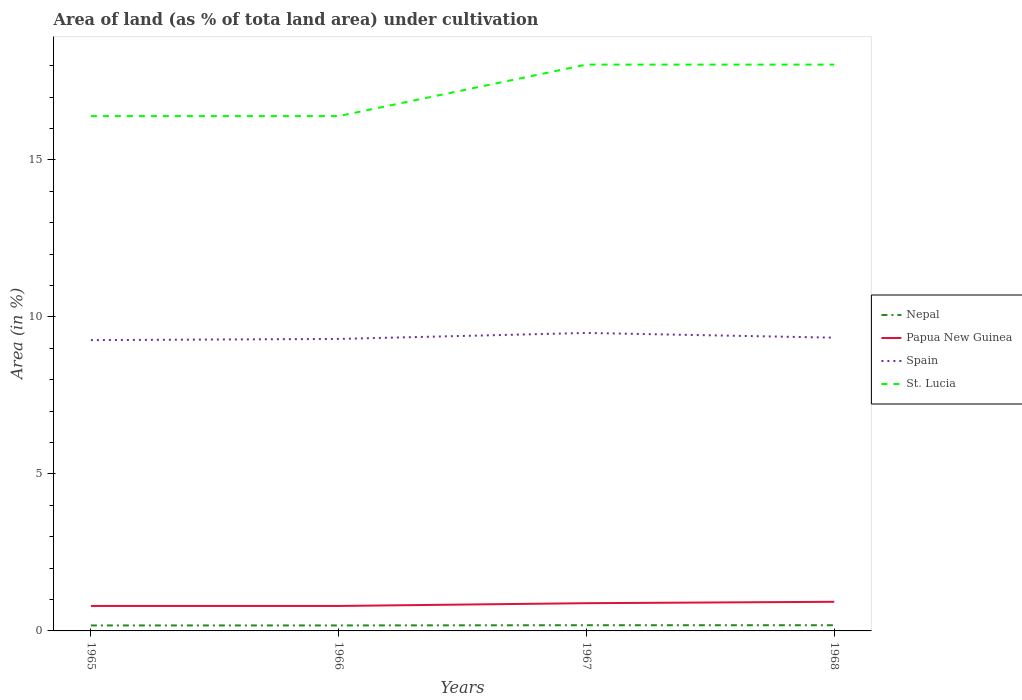Is the number of lines equal to the number of legend labels?
Ensure brevity in your answer.  Yes. Across all years, what is the maximum percentage of land under cultivation in Spain?
Offer a very short reply. 9.26. In which year was the percentage of land under cultivation in Papua New Guinea maximum?
Your answer should be very brief. 1965. What is the total percentage of land under cultivation in St. Lucia in the graph?
Your response must be concise. 0. What is the difference between the highest and the second highest percentage of land under cultivation in Papua New Guinea?
Provide a succinct answer. 0.13. Is the percentage of land under cultivation in Spain strictly greater than the percentage of land under cultivation in St. Lucia over the years?
Your answer should be compact. Yes. Does the graph contain grids?
Provide a succinct answer. No. Where does the legend appear in the graph?
Offer a terse response. Center right. How many legend labels are there?
Provide a succinct answer. 4. What is the title of the graph?
Provide a succinct answer. Area of land (as % of tota land area) under cultivation. What is the label or title of the Y-axis?
Your answer should be very brief. Area (in %). What is the Area (in %) in Nepal in 1965?
Your response must be concise. 0.17. What is the Area (in %) in Papua New Guinea in 1965?
Provide a succinct answer. 0.79. What is the Area (in %) in Spain in 1965?
Your response must be concise. 9.26. What is the Area (in %) of St. Lucia in 1965?
Give a very brief answer. 16.39. What is the Area (in %) in Nepal in 1966?
Make the answer very short. 0.17. What is the Area (in %) in Papua New Guinea in 1966?
Give a very brief answer. 0.79. What is the Area (in %) in Spain in 1966?
Provide a succinct answer. 9.3. What is the Area (in %) in St. Lucia in 1966?
Provide a short and direct response. 16.39. What is the Area (in %) of Nepal in 1967?
Your answer should be very brief. 0.18. What is the Area (in %) in Papua New Guinea in 1967?
Your answer should be very brief. 0.88. What is the Area (in %) of Spain in 1967?
Your answer should be compact. 9.49. What is the Area (in %) in St. Lucia in 1967?
Offer a very short reply. 18.03. What is the Area (in %) of Nepal in 1968?
Ensure brevity in your answer.  0.18. What is the Area (in %) in Papua New Guinea in 1968?
Provide a short and direct response. 0.93. What is the Area (in %) of Spain in 1968?
Offer a very short reply. 9.34. What is the Area (in %) of St. Lucia in 1968?
Keep it short and to the point. 18.03. Across all years, what is the maximum Area (in %) in Nepal?
Make the answer very short. 0.18. Across all years, what is the maximum Area (in %) in Papua New Guinea?
Keep it short and to the point. 0.93. Across all years, what is the maximum Area (in %) in Spain?
Your answer should be compact. 9.49. Across all years, what is the maximum Area (in %) of St. Lucia?
Ensure brevity in your answer.  18.03. Across all years, what is the minimum Area (in %) of Nepal?
Ensure brevity in your answer.  0.17. Across all years, what is the minimum Area (in %) of Papua New Guinea?
Keep it short and to the point. 0.79. Across all years, what is the minimum Area (in %) in Spain?
Give a very brief answer. 9.26. Across all years, what is the minimum Area (in %) in St. Lucia?
Offer a very short reply. 16.39. What is the total Area (in %) of Nepal in the graph?
Ensure brevity in your answer.  0.71. What is the total Area (in %) in Papua New Guinea in the graph?
Give a very brief answer. 3.4. What is the total Area (in %) in Spain in the graph?
Your answer should be very brief. 37.38. What is the total Area (in %) in St. Lucia in the graph?
Provide a short and direct response. 68.85. What is the difference between the Area (in %) of Nepal in 1965 and that in 1966?
Offer a terse response. 0. What is the difference between the Area (in %) in Spain in 1965 and that in 1966?
Your answer should be compact. -0.04. What is the difference between the Area (in %) of Nepal in 1965 and that in 1967?
Your response must be concise. -0.01. What is the difference between the Area (in %) in Papua New Guinea in 1965 and that in 1967?
Offer a terse response. -0.09. What is the difference between the Area (in %) in Spain in 1965 and that in 1967?
Make the answer very short. -0.23. What is the difference between the Area (in %) of St. Lucia in 1965 and that in 1967?
Offer a very short reply. -1.64. What is the difference between the Area (in %) of Nepal in 1965 and that in 1968?
Make the answer very short. -0.01. What is the difference between the Area (in %) of Papua New Guinea in 1965 and that in 1968?
Your answer should be compact. -0.13. What is the difference between the Area (in %) of Spain in 1965 and that in 1968?
Your response must be concise. -0.08. What is the difference between the Area (in %) in St. Lucia in 1965 and that in 1968?
Make the answer very short. -1.64. What is the difference between the Area (in %) in Nepal in 1966 and that in 1967?
Give a very brief answer. -0.01. What is the difference between the Area (in %) in Papua New Guinea in 1966 and that in 1967?
Provide a short and direct response. -0.09. What is the difference between the Area (in %) in Spain in 1966 and that in 1967?
Make the answer very short. -0.19. What is the difference between the Area (in %) in St. Lucia in 1966 and that in 1967?
Provide a succinct answer. -1.64. What is the difference between the Area (in %) in Nepal in 1966 and that in 1968?
Your response must be concise. -0.01. What is the difference between the Area (in %) of Papua New Guinea in 1966 and that in 1968?
Your answer should be very brief. -0.13. What is the difference between the Area (in %) in Spain in 1966 and that in 1968?
Make the answer very short. -0.04. What is the difference between the Area (in %) in St. Lucia in 1966 and that in 1968?
Your response must be concise. -1.64. What is the difference between the Area (in %) in Nepal in 1967 and that in 1968?
Provide a succinct answer. 0. What is the difference between the Area (in %) of Papua New Guinea in 1967 and that in 1968?
Your answer should be compact. -0.04. What is the difference between the Area (in %) in Spain in 1967 and that in 1968?
Your answer should be very brief. 0.15. What is the difference between the Area (in %) in St. Lucia in 1967 and that in 1968?
Ensure brevity in your answer.  0. What is the difference between the Area (in %) in Nepal in 1965 and the Area (in %) in Papua New Guinea in 1966?
Your answer should be compact. -0.62. What is the difference between the Area (in %) in Nepal in 1965 and the Area (in %) in Spain in 1966?
Provide a succinct answer. -9.12. What is the difference between the Area (in %) in Nepal in 1965 and the Area (in %) in St. Lucia in 1966?
Offer a terse response. -16.22. What is the difference between the Area (in %) of Papua New Guinea in 1965 and the Area (in %) of Spain in 1966?
Ensure brevity in your answer.  -8.5. What is the difference between the Area (in %) in Papua New Guinea in 1965 and the Area (in %) in St. Lucia in 1966?
Offer a very short reply. -15.6. What is the difference between the Area (in %) of Spain in 1965 and the Area (in %) of St. Lucia in 1966?
Ensure brevity in your answer.  -7.13. What is the difference between the Area (in %) of Nepal in 1965 and the Area (in %) of Papua New Guinea in 1967?
Make the answer very short. -0.71. What is the difference between the Area (in %) in Nepal in 1965 and the Area (in %) in Spain in 1967?
Your answer should be compact. -9.31. What is the difference between the Area (in %) of Nepal in 1965 and the Area (in %) of St. Lucia in 1967?
Ensure brevity in your answer.  -17.86. What is the difference between the Area (in %) in Papua New Guinea in 1965 and the Area (in %) in Spain in 1967?
Ensure brevity in your answer.  -8.69. What is the difference between the Area (in %) of Papua New Guinea in 1965 and the Area (in %) of St. Lucia in 1967?
Give a very brief answer. -17.24. What is the difference between the Area (in %) in Spain in 1965 and the Area (in %) in St. Lucia in 1967?
Provide a succinct answer. -8.77. What is the difference between the Area (in %) of Nepal in 1965 and the Area (in %) of Papua New Guinea in 1968?
Your answer should be compact. -0.75. What is the difference between the Area (in %) in Nepal in 1965 and the Area (in %) in Spain in 1968?
Offer a very short reply. -9.16. What is the difference between the Area (in %) in Nepal in 1965 and the Area (in %) in St. Lucia in 1968?
Provide a succinct answer. -17.86. What is the difference between the Area (in %) of Papua New Guinea in 1965 and the Area (in %) of Spain in 1968?
Provide a succinct answer. -8.54. What is the difference between the Area (in %) in Papua New Guinea in 1965 and the Area (in %) in St. Lucia in 1968?
Provide a short and direct response. -17.24. What is the difference between the Area (in %) in Spain in 1965 and the Area (in %) in St. Lucia in 1968?
Offer a very short reply. -8.77. What is the difference between the Area (in %) of Nepal in 1966 and the Area (in %) of Papua New Guinea in 1967?
Make the answer very short. -0.71. What is the difference between the Area (in %) of Nepal in 1966 and the Area (in %) of Spain in 1967?
Give a very brief answer. -9.31. What is the difference between the Area (in %) of Nepal in 1966 and the Area (in %) of St. Lucia in 1967?
Your answer should be compact. -17.86. What is the difference between the Area (in %) in Papua New Guinea in 1966 and the Area (in %) in Spain in 1967?
Make the answer very short. -8.69. What is the difference between the Area (in %) of Papua New Guinea in 1966 and the Area (in %) of St. Lucia in 1967?
Your answer should be compact. -17.24. What is the difference between the Area (in %) of Spain in 1966 and the Area (in %) of St. Lucia in 1967?
Provide a short and direct response. -8.73. What is the difference between the Area (in %) of Nepal in 1966 and the Area (in %) of Papua New Guinea in 1968?
Your answer should be compact. -0.75. What is the difference between the Area (in %) of Nepal in 1966 and the Area (in %) of Spain in 1968?
Provide a short and direct response. -9.16. What is the difference between the Area (in %) in Nepal in 1966 and the Area (in %) in St. Lucia in 1968?
Your answer should be compact. -17.86. What is the difference between the Area (in %) of Papua New Guinea in 1966 and the Area (in %) of Spain in 1968?
Provide a succinct answer. -8.54. What is the difference between the Area (in %) in Papua New Guinea in 1966 and the Area (in %) in St. Lucia in 1968?
Provide a succinct answer. -17.24. What is the difference between the Area (in %) of Spain in 1966 and the Area (in %) of St. Lucia in 1968?
Make the answer very short. -8.73. What is the difference between the Area (in %) in Nepal in 1967 and the Area (in %) in Papua New Guinea in 1968?
Provide a succinct answer. -0.75. What is the difference between the Area (in %) in Nepal in 1967 and the Area (in %) in Spain in 1968?
Your answer should be compact. -9.16. What is the difference between the Area (in %) of Nepal in 1967 and the Area (in %) of St. Lucia in 1968?
Provide a succinct answer. -17.85. What is the difference between the Area (in %) in Papua New Guinea in 1967 and the Area (in %) in Spain in 1968?
Your response must be concise. -8.45. What is the difference between the Area (in %) in Papua New Guinea in 1967 and the Area (in %) in St. Lucia in 1968?
Keep it short and to the point. -17.15. What is the difference between the Area (in %) of Spain in 1967 and the Area (in %) of St. Lucia in 1968?
Your answer should be compact. -8.54. What is the average Area (in %) in Nepal per year?
Your answer should be compact. 0.18. What is the average Area (in %) in Papua New Guinea per year?
Ensure brevity in your answer.  0.85. What is the average Area (in %) of Spain per year?
Your answer should be compact. 9.35. What is the average Area (in %) of St. Lucia per year?
Keep it short and to the point. 17.21. In the year 1965, what is the difference between the Area (in %) of Nepal and Area (in %) of Papua New Guinea?
Make the answer very short. -0.62. In the year 1965, what is the difference between the Area (in %) in Nepal and Area (in %) in Spain?
Provide a succinct answer. -9.09. In the year 1965, what is the difference between the Area (in %) of Nepal and Area (in %) of St. Lucia?
Your answer should be very brief. -16.22. In the year 1965, what is the difference between the Area (in %) of Papua New Guinea and Area (in %) of Spain?
Your response must be concise. -8.47. In the year 1965, what is the difference between the Area (in %) in Papua New Guinea and Area (in %) in St. Lucia?
Your answer should be very brief. -15.6. In the year 1965, what is the difference between the Area (in %) of Spain and Area (in %) of St. Lucia?
Provide a short and direct response. -7.13. In the year 1966, what is the difference between the Area (in %) of Nepal and Area (in %) of Papua New Guinea?
Make the answer very short. -0.62. In the year 1966, what is the difference between the Area (in %) of Nepal and Area (in %) of Spain?
Ensure brevity in your answer.  -9.12. In the year 1966, what is the difference between the Area (in %) of Nepal and Area (in %) of St. Lucia?
Keep it short and to the point. -16.22. In the year 1966, what is the difference between the Area (in %) in Papua New Guinea and Area (in %) in Spain?
Your answer should be very brief. -8.5. In the year 1966, what is the difference between the Area (in %) in Papua New Guinea and Area (in %) in St. Lucia?
Provide a short and direct response. -15.6. In the year 1966, what is the difference between the Area (in %) of Spain and Area (in %) of St. Lucia?
Offer a very short reply. -7.1. In the year 1967, what is the difference between the Area (in %) in Nepal and Area (in %) in Papua New Guinea?
Ensure brevity in your answer.  -0.7. In the year 1967, what is the difference between the Area (in %) of Nepal and Area (in %) of Spain?
Ensure brevity in your answer.  -9.31. In the year 1967, what is the difference between the Area (in %) of Nepal and Area (in %) of St. Lucia?
Your response must be concise. -17.85. In the year 1967, what is the difference between the Area (in %) of Papua New Guinea and Area (in %) of Spain?
Keep it short and to the point. -8.6. In the year 1967, what is the difference between the Area (in %) in Papua New Guinea and Area (in %) in St. Lucia?
Offer a terse response. -17.15. In the year 1967, what is the difference between the Area (in %) in Spain and Area (in %) in St. Lucia?
Offer a very short reply. -8.54. In the year 1968, what is the difference between the Area (in %) in Nepal and Area (in %) in Papua New Guinea?
Provide a short and direct response. -0.75. In the year 1968, what is the difference between the Area (in %) of Nepal and Area (in %) of Spain?
Provide a succinct answer. -9.16. In the year 1968, what is the difference between the Area (in %) of Nepal and Area (in %) of St. Lucia?
Give a very brief answer. -17.85. In the year 1968, what is the difference between the Area (in %) of Papua New Guinea and Area (in %) of Spain?
Your response must be concise. -8.41. In the year 1968, what is the difference between the Area (in %) in Papua New Guinea and Area (in %) in St. Lucia?
Ensure brevity in your answer.  -17.11. In the year 1968, what is the difference between the Area (in %) of Spain and Area (in %) of St. Lucia?
Provide a short and direct response. -8.69. What is the ratio of the Area (in %) in Nepal in 1965 to that in 1966?
Your answer should be compact. 1. What is the ratio of the Area (in %) of Nepal in 1965 to that in 1967?
Provide a short and direct response. 0.96. What is the ratio of the Area (in %) in Papua New Guinea in 1965 to that in 1967?
Offer a terse response. 0.9. What is the ratio of the Area (in %) in Spain in 1965 to that in 1967?
Your response must be concise. 0.98. What is the ratio of the Area (in %) in St. Lucia in 1965 to that in 1967?
Your response must be concise. 0.91. What is the ratio of the Area (in %) of Nepal in 1965 to that in 1968?
Give a very brief answer. 0.96. What is the ratio of the Area (in %) in Papua New Guinea in 1965 to that in 1968?
Make the answer very short. 0.86. What is the ratio of the Area (in %) in Spain in 1965 to that in 1968?
Keep it short and to the point. 0.99. What is the ratio of the Area (in %) of St. Lucia in 1965 to that in 1968?
Keep it short and to the point. 0.91. What is the ratio of the Area (in %) of Nepal in 1966 to that in 1967?
Provide a succinct answer. 0.96. What is the ratio of the Area (in %) in Spain in 1966 to that in 1967?
Offer a terse response. 0.98. What is the ratio of the Area (in %) in St. Lucia in 1966 to that in 1967?
Give a very brief answer. 0.91. What is the ratio of the Area (in %) of Nepal in 1966 to that in 1968?
Offer a terse response. 0.96. What is the ratio of the Area (in %) in Spain in 1967 to that in 1968?
Your response must be concise. 1.02. What is the ratio of the Area (in %) of St. Lucia in 1967 to that in 1968?
Provide a short and direct response. 1. What is the difference between the highest and the second highest Area (in %) in Nepal?
Keep it short and to the point. 0. What is the difference between the highest and the second highest Area (in %) of Papua New Guinea?
Make the answer very short. 0.04. What is the difference between the highest and the second highest Area (in %) of Spain?
Your answer should be very brief. 0.15. What is the difference between the highest and the second highest Area (in %) in St. Lucia?
Keep it short and to the point. 0. What is the difference between the highest and the lowest Area (in %) of Nepal?
Your answer should be compact. 0.01. What is the difference between the highest and the lowest Area (in %) of Papua New Guinea?
Make the answer very short. 0.13. What is the difference between the highest and the lowest Area (in %) in Spain?
Your response must be concise. 0.23. What is the difference between the highest and the lowest Area (in %) in St. Lucia?
Offer a very short reply. 1.64. 